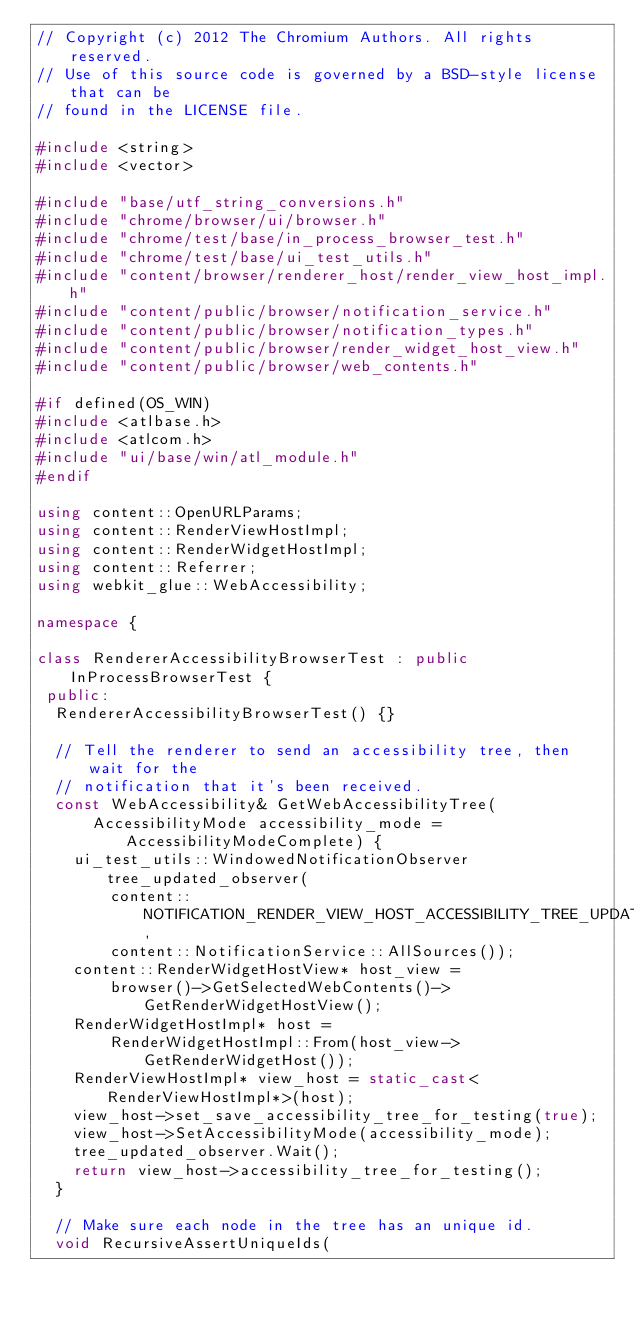<code> <loc_0><loc_0><loc_500><loc_500><_C++_>// Copyright (c) 2012 The Chromium Authors. All rights reserved.
// Use of this source code is governed by a BSD-style license that can be
// found in the LICENSE file.

#include <string>
#include <vector>

#include "base/utf_string_conversions.h"
#include "chrome/browser/ui/browser.h"
#include "chrome/test/base/in_process_browser_test.h"
#include "chrome/test/base/ui_test_utils.h"
#include "content/browser/renderer_host/render_view_host_impl.h"
#include "content/public/browser/notification_service.h"
#include "content/public/browser/notification_types.h"
#include "content/public/browser/render_widget_host_view.h"
#include "content/public/browser/web_contents.h"

#if defined(OS_WIN)
#include <atlbase.h>
#include <atlcom.h>
#include "ui/base/win/atl_module.h"
#endif

using content::OpenURLParams;
using content::RenderViewHostImpl;
using content::RenderWidgetHostImpl;
using content::Referrer;
using webkit_glue::WebAccessibility;

namespace {

class RendererAccessibilityBrowserTest : public InProcessBrowserTest {
 public:
  RendererAccessibilityBrowserTest() {}

  // Tell the renderer to send an accessibility tree, then wait for the
  // notification that it's been received.
  const WebAccessibility& GetWebAccessibilityTree(
      AccessibilityMode accessibility_mode = AccessibilityModeComplete) {
    ui_test_utils::WindowedNotificationObserver tree_updated_observer(
        content::NOTIFICATION_RENDER_VIEW_HOST_ACCESSIBILITY_TREE_UPDATED,
        content::NotificationService::AllSources());
    content::RenderWidgetHostView* host_view =
        browser()->GetSelectedWebContents()->GetRenderWidgetHostView();
    RenderWidgetHostImpl* host =
        RenderWidgetHostImpl::From(host_view->GetRenderWidgetHost());
    RenderViewHostImpl* view_host = static_cast<RenderViewHostImpl*>(host);
    view_host->set_save_accessibility_tree_for_testing(true);
    view_host->SetAccessibilityMode(accessibility_mode);
    tree_updated_observer.Wait();
    return view_host->accessibility_tree_for_testing();
  }

  // Make sure each node in the tree has an unique id.
  void RecursiveAssertUniqueIds(</code> 